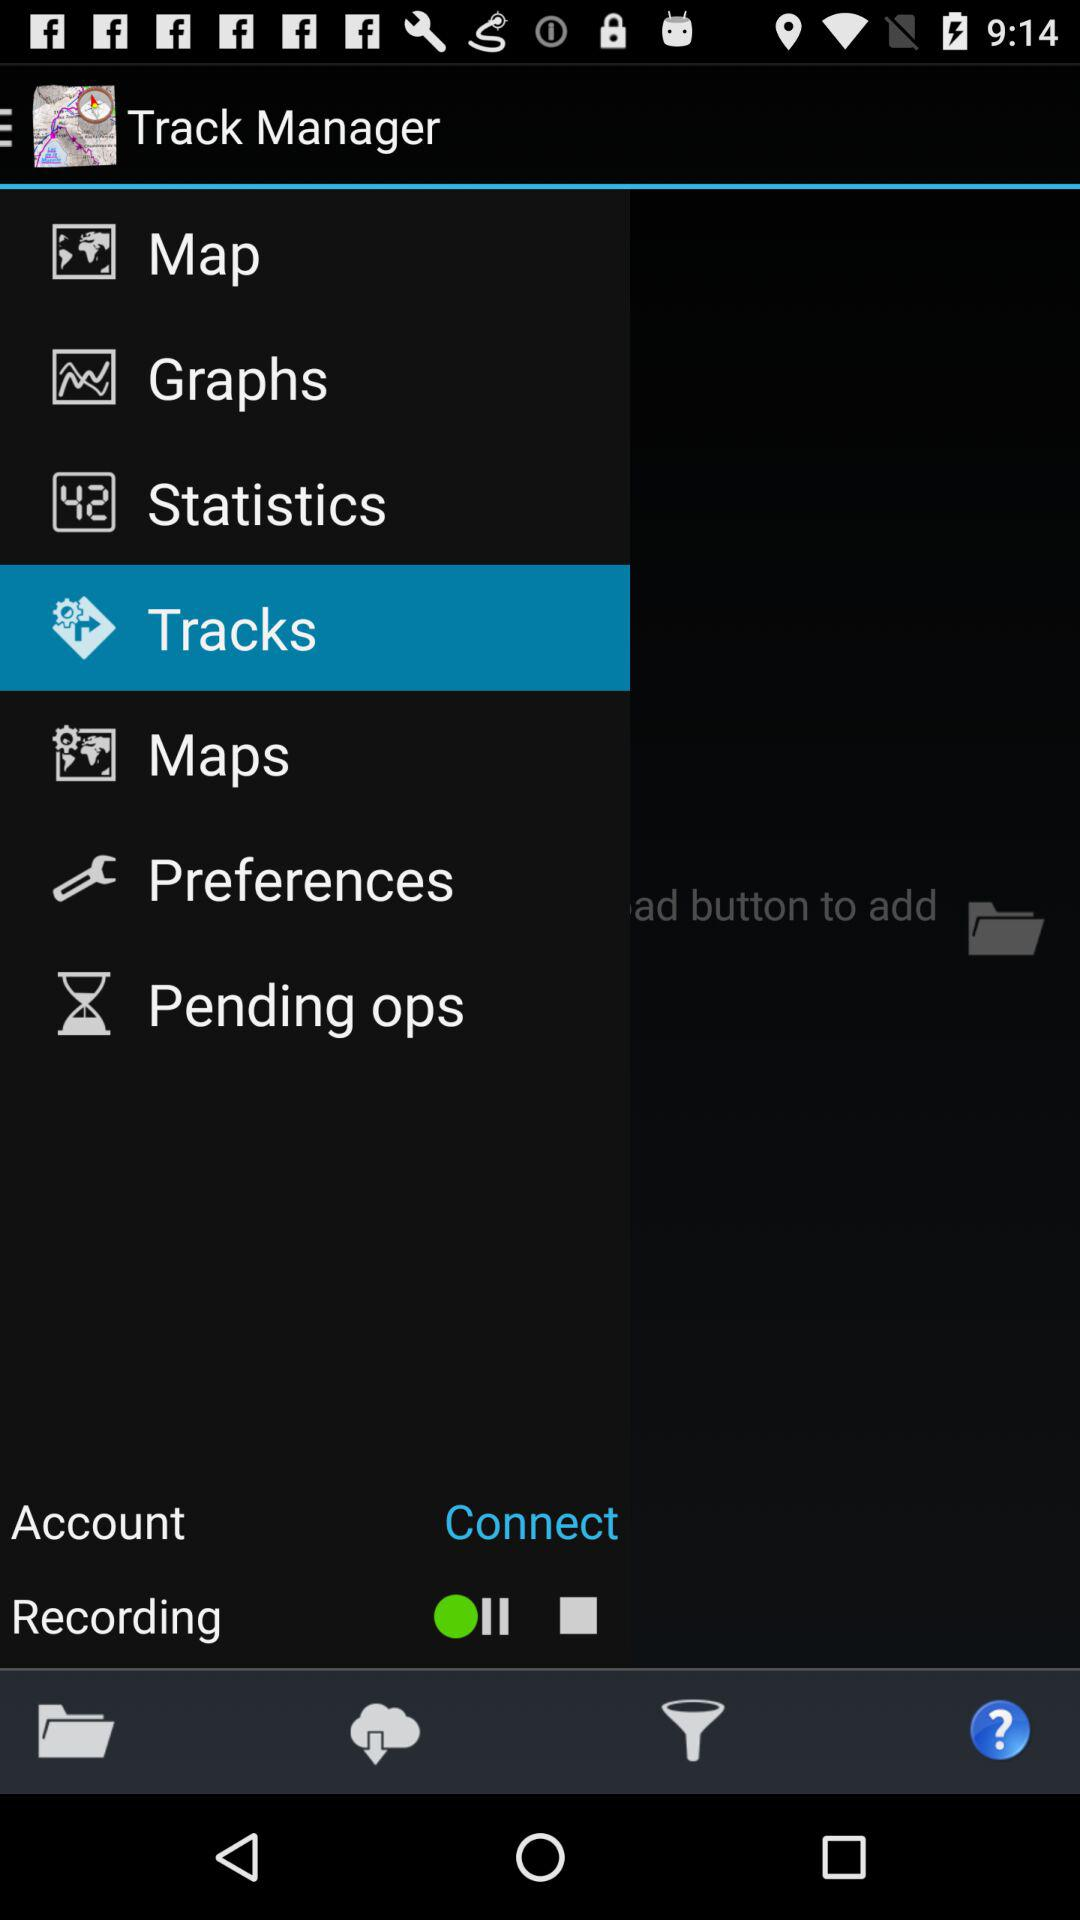What is the application name? The application name is "Track Manager". 